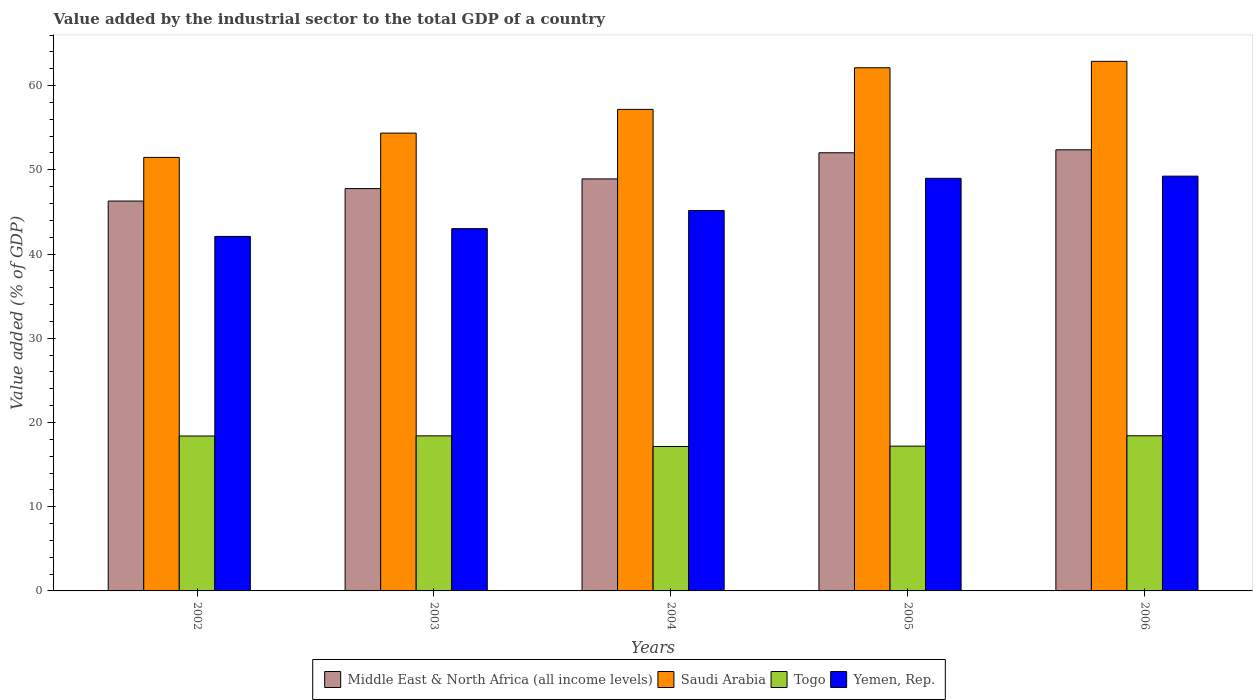How many groups of bars are there?
Offer a very short reply. 5. How many bars are there on the 4th tick from the left?
Ensure brevity in your answer.  4. How many bars are there on the 5th tick from the right?
Your answer should be very brief. 4. What is the value added by the industrial sector to the total GDP in Yemen, Rep. in 2004?
Your answer should be compact. 45.16. Across all years, what is the maximum value added by the industrial sector to the total GDP in Saudi Arabia?
Make the answer very short. 62.88. Across all years, what is the minimum value added by the industrial sector to the total GDP in Yemen, Rep.?
Keep it short and to the point. 42.09. In which year was the value added by the industrial sector to the total GDP in Yemen, Rep. minimum?
Your answer should be compact. 2002. What is the total value added by the industrial sector to the total GDP in Togo in the graph?
Make the answer very short. 89.56. What is the difference between the value added by the industrial sector to the total GDP in Togo in 2005 and that in 2006?
Your answer should be compact. -1.23. What is the difference between the value added by the industrial sector to the total GDP in Yemen, Rep. in 2006 and the value added by the industrial sector to the total GDP in Saudi Arabia in 2004?
Keep it short and to the point. -7.93. What is the average value added by the industrial sector to the total GDP in Togo per year?
Keep it short and to the point. 17.91. In the year 2002, what is the difference between the value added by the industrial sector to the total GDP in Yemen, Rep. and value added by the industrial sector to the total GDP in Middle East & North Africa (all income levels)?
Provide a short and direct response. -4.2. In how many years, is the value added by the industrial sector to the total GDP in Saudi Arabia greater than 56 %?
Provide a succinct answer. 3. What is the ratio of the value added by the industrial sector to the total GDP in Middle East & North Africa (all income levels) in 2002 to that in 2003?
Offer a very short reply. 0.97. Is the difference between the value added by the industrial sector to the total GDP in Yemen, Rep. in 2003 and 2005 greater than the difference between the value added by the industrial sector to the total GDP in Middle East & North Africa (all income levels) in 2003 and 2005?
Provide a succinct answer. No. What is the difference between the highest and the second highest value added by the industrial sector to the total GDP in Togo?
Ensure brevity in your answer.  0.01. What is the difference between the highest and the lowest value added by the industrial sector to the total GDP in Togo?
Give a very brief answer. 1.28. In how many years, is the value added by the industrial sector to the total GDP in Middle East & North Africa (all income levels) greater than the average value added by the industrial sector to the total GDP in Middle East & North Africa (all income levels) taken over all years?
Offer a terse response. 2. Is the sum of the value added by the industrial sector to the total GDP in Yemen, Rep. in 2002 and 2004 greater than the maximum value added by the industrial sector to the total GDP in Saudi Arabia across all years?
Provide a short and direct response. Yes. Is it the case that in every year, the sum of the value added by the industrial sector to the total GDP in Middle East & North Africa (all income levels) and value added by the industrial sector to the total GDP in Yemen, Rep. is greater than the sum of value added by the industrial sector to the total GDP in Saudi Arabia and value added by the industrial sector to the total GDP in Togo?
Your response must be concise. No. What does the 3rd bar from the left in 2006 represents?
Offer a terse response. Togo. What does the 1st bar from the right in 2002 represents?
Your response must be concise. Yemen, Rep. Is it the case that in every year, the sum of the value added by the industrial sector to the total GDP in Middle East & North Africa (all income levels) and value added by the industrial sector to the total GDP in Togo is greater than the value added by the industrial sector to the total GDP in Yemen, Rep.?
Your answer should be very brief. Yes. How many years are there in the graph?
Your answer should be very brief. 5. Does the graph contain any zero values?
Your response must be concise. No. Does the graph contain grids?
Offer a very short reply. No. How are the legend labels stacked?
Your answer should be very brief. Horizontal. What is the title of the graph?
Give a very brief answer. Value added by the industrial sector to the total GDP of a country. Does "Vietnam" appear as one of the legend labels in the graph?
Your response must be concise. No. What is the label or title of the X-axis?
Provide a short and direct response. Years. What is the label or title of the Y-axis?
Your answer should be compact. Value added (% of GDP). What is the Value added (% of GDP) of Middle East & North Africa (all income levels) in 2002?
Make the answer very short. 46.29. What is the Value added (% of GDP) of Saudi Arabia in 2002?
Provide a succinct answer. 51.47. What is the Value added (% of GDP) of Togo in 2002?
Provide a short and direct response. 18.39. What is the Value added (% of GDP) of Yemen, Rep. in 2002?
Give a very brief answer. 42.09. What is the Value added (% of GDP) of Middle East & North Africa (all income levels) in 2003?
Keep it short and to the point. 47.77. What is the Value added (% of GDP) in Saudi Arabia in 2003?
Provide a succinct answer. 54.36. What is the Value added (% of GDP) of Togo in 2003?
Your response must be concise. 18.41. What is the Value added (% of GDP) of Yemen, Rep. in 2003?
Make the answer very short. 43.01. What is the Value added (% of GDP) in Middle East & North Africa (all income levels) in 2004?
Give a very brief answer. 48.92. What is the Value added (% of GDP) of Saudi Arabia in 2004?
Offer a terse response. 57.17. What is the Value added (% of GDP) in Togo in 2004?
Offer a very short reply. 17.15. What is the Value added (% of GDP) of Yemen, Rep. in 2004?
Provide a succinct answer. 45.16. What is the Value added (% of GDP) of Middle East & North Africa (all income levels) in 2005?
Your answer should be very brief. 52.02. What is the Value added (% of GDP) in Saudi Arabia in 2005?
Offer a very short reply. 62.11. What is the Value added (% of GDP) of Togo in 2005?
Keep it short and to the point. 17.19. What is the Value added (% of GDP) in Yemen, Rep. in 2005?
Keep it short and to the point. 48.99. What is the Value added (% of GDP) in Middle East & North Africa (all income levels) in 2006?
Provide a succinct answer. 52.37. What is the Value added (% of GDP) of Saudi Arabia in 2006?
Your answer should be compact. 62.88. What is the Value added (% of GDP) in Togo in 2006?
Your response must be concise. 18.42. What is the Value added (% of GDP) of Yemen, Rep. in 2006?
Provide a succinct answer. 49.25. Across all years, what is the maximum Value added (% of GDP) of Middle East & North Africa (all income levels)?
Provide a short and direct response. 52.37. Across all years, what is the maximum Value added (% of GDP) in Saudi Arabia?
Keep it short and to the point. 62.88. Across all years, what is the maximum Value added (% of GDP) in Togo?
Your response must be concise. 18.42. Across all years, what is the maximum Value added (% of GDP) of Yemen, Rep.?
Provide a succinct answer. 49.25. Across all years, what is the minimum Value added (% of GDP) in Middle East & North Africa (all income levels)?
Offer a terse response. 46.29. Across all years, what is the minimum Value added (% of GDP) in Saudi Arabia?
Provide a succinct answer. 51.47. Across all years, what is the minimum Value added (% of GDP) of Togo?
Your response must be concise. 17.15. Across all years, what is the minimum Value added (% of GDP) of Yemen, Rep.?
Your answer should be compact. 42.09. What is the total Value added (% of GDP) of Middle East & North Africa (all income levels) in the graph?
Provide a short and direct response. 247.38. What is the total Value added (% of GDP) in Saudi Arabia in the graph?
Make the answer very short. 288. What is the total Value added (% of GDP) of Togo in the graph?
Give a very brief answer. 89.56. What is the total Value added (% of GDP) of Yemen, Rep. in the graph?
Give a very brief answer. 228.5. What is the difference between the Value added (% of GDP) in Middle East & North Africa (all income levels) in 2002 and that in 2003?
Provide a short and direct response. -1.48. What is the difference between the Value added (% of GDP) of Saudi Arabia in 2002 and that in 2003?
Your answer should be compact. -2.89. What is the difference between the Value added (% of GDP) in Togo in 2002 and that in 2003?
Make the answer very short. -0.02. What is the difference between the Value added (% of GDP) in Yemen, Rep. in 2002 and that in 2003?
Your answer should be very brief. -0.93. What is the difference between the Value added (% of GDP) of Middle East & North Africa (all income levels) in 2002 and that in 2004?
Make the answer very short. -2.63. What is the difference between the Value added (% of GDP) in Saudi Arabia in 2002 and that in 2004?
Keep it short and to the point. -5.7. What is the difference between the Value added (% of GDP) of Togo in 2002 and that in 2004?
Provide a short and direct response. 1.25. What is the difference between the Value added (% of GDP) of Yemen, Rep. in 2002 and that in 2004?
Provide a succinct answer. -3.08. What is the difference between the Value added (% of GDP) of Middle East & North Africa (all income levels) in 2002 and that in 2005?
Your answer should be very brief. -5.73. What is the difference between the Value added (% of GDP) in Saudi Arabia in 2002 and that in 2005?
Make the answer very short. -10.64. What is the difference between the Value added (% of GDP) of Togo in 2002 and that in 2005?
Your answer should be very brief. 1.2. What is the difference between the Value added (% of GDP) of Yemen, Rep. in 2002 and that in 2005?
Your answer should be compact. -6.9. What is the difference between the Value added (% of GDP) in Middle East & North Africa (all income levels) in 2002 and that in 2006?
Give a very brief answer. -6.08. What is the difference between the Value added (% of GDP) of Saudi Arabia in 2002 and that in 2006?
Your answer should be very brief. -11.4. What is the difference between the Value added (% of GDP) of Togo in 2002 and that in 2006?
Provide a succinct answer. -0.03. What is the difference between the Value added (% of GDP) of Yemen, Rep. in 2002 and that in 2006?
Give a very brief answer. -7.16. What is the difference between the Value added (% of GDP) in Middle East & North Africa (all income levels) in 2003 and that in 2004?
Ensure brevity in your answer.  -1.15. What is the difference between the Value added (% of GDP) of Saudi Arabia in 2003 and that in 2004?
Your answer should be compact. -2.82. What is the difference between the Value added (% of GDP) of Togo in 2003 and that in 2004?
Give a very brief answer. 1.26. What is the difference between the Value added (% of GDP) in Yemen, Rep. in 2003 and that in 2004?
Your answer should be compact. -2.15. What is the difference between the Value added (% of GDP) in Middle East & North Africa (all income levels) in 2003 and that in 2005?
Ensure brevity in your answer.  -4.25. What is the difference between the Value added (% of GDP) in Saudi Arabia in 2003 and that in 2005?
Offer a very short reply. -7.76. What is the difference between the Value added (% of GDP) of Togo in 2003 and that in 2005?
Make the answer very short. 1.22. What is the difference between the Value added (% of GDP) in Yemen, Rep. in 2003 and that in 2005?
Provide a short and direct response. -5.97. What is the difference between the Value added (% of GDP) in Middle East & North Africa (all income levels) in 2003 and that in 2006?
Make the answer very short. -4.61. What is the difference between the Value added (% of GDP) in Saudi Arabia in 2003 and that in 2006?
Keep it short and to the point. -8.52. What is the difference between the Value added (% of GDP) in Togo in 2003 and that in 2006?
Ensure brevity in your answer.  -0.01. What is the difference between the Value added (% of GDP) of Yemen, Rep. in 2003 and that in 2006?
Keep it short and to the point. -6.23. What is the difference between the Value added (% of GDP) in Middle East & North Africa (all income levels) in 2004 and that in 2005?
Offer a very short reply. -3.1. What is the difference between the Value added (% of GDP) of Saudi Arabia in 2004 and that in 2005?
Offer a very short reply. -4.94. What is the difference between the Value added (% of GDP) in Togo in 2004 and that in 2005?
Make the answer very short. -0.04. What is the difference between the Value added (% of GDP) of Yemen, Rep. in 2004 and that in 2005?
Offer a very short reply. -3.83. What is the difference between the Value added (% of GDP) in Middle East & North Africa (all income levels) in 2004 and that in 2006?
Your answer should be very brief. -3.46. What is the difference between the Value added (% of GDP) of Saudi Arabia in 2004 and that in 2006?
Offer a very short reply. -5.7. What is the difference between the Value added (% of GDP) in Togo in 2004 and that in 2006?
Offer a terse response. -1.28. What is the difference between the Value added (% of GDP) in Yemen, Rep. in 2004 and that in 2006?
Provide a short and direct response. -4.08. What is the difference between the Value added (% of GDP) in Middle East & North Africa (all income levels) in 2005 and that in 2006?
Offer a very short reply. -0.35. What is the difference between the Value added (% of GDP) in Saudi Arabia in 2005 and that in 2006?
Offer a terse response. -0.76. What is the difference between the Value added (% of GDP) in Togo in 2005 and that in 2006?
Offer a terse response. -1.23. What is the difference between the Value added (% of GDP) in Yemen, Rep. in 2005 and that in 2006?
Ensure brevity in your answer.  -0.26. What is the difference between the Value added (% of GDP) in Middle East & North Africa (all income levels) in 2002 and the Value added (% of GDP) in Saudi Arabia in 2003?
Keep it short and to the point. -8.07. What is the difference between the Value added (% of GDP) in Middle East & North Africa (all income levels) in 2002 and the Value added (% of GDP) in Togo in 2003?
Give a very brief answer. 27.88. What is the difference between the Value added (% of GDP) of Middle East & North Africa (all income levels) in 2002 and the Value added (% of GDP) of Yemen, Rep. in 2003?
Offer a very short reply. 3.28. What is the difference between the Value added (% of GDP) in Saudi Arabia in 2002 and the Value added (% of GDP) in Togo in 2003?
Keep it short and to the point. 33.06. What is the difference between the Value added (% of GDP) in Saudi Arabia in 2002 and the Value added (% of GDP) in Yemen, Rep. in 2003?
Keep it short and to the point. 8.46. What is the difference between the Value added (% of GDP) of Togo in 2002 and the Value added (% of GDP) of Yemen, Rep. in 2003?
Your answer should be compact. -24.62. What is the difference between the Value added (% of GDP) in Middle East & North Africa (all income levels) in 2002 and the Value added (% of GDP) in Saudi Arabia in 2004?
Provide a succinct answer. -10.88. What is the difference between the Value added (% of GDP) in Middle East & North Africa (all income levels) in 2002 and the Value added (% of GDP) in Togo in 2004?
Provide a short and direct response. 29.14. What is the difference between the Value added (% of GDP) in Middle East & North Africa (all income levels) in 2002 and the Value added (% of GDP) in Yemen, Rep. in 2004?
Offer a terse response. 1.13. What is the difference between the Value added (% of GDP) in Saudi Arabia in 2002 and the Value added (% of GDP) in Togo in 2004?
Ensure brevity in your answer.  34.33. What is the difference between the Value added (% of GDP) in Saudi Arabia in 2002 and the Value added (% of GDP) in Yemen, Rep. in 2004?
Offer a very short reply. 6.31. What is the difference between the Value added (% of GDP) in Togo in 2002 and the Value added (% of GDP) in Yemen, Rep. in 2004?
Offer a terse response. -26.77. What is the difference between the Value added (% of GDP) of Middle East & North Africa (all income levels) in 2002 and the Value added (% of GDP) of Saudi Arabia in 2005?
Your answer should be very brief. -15.82. What is the difference between the Value added (% of GDP) of Middle East & North Africa (all income levels) in 2002 and the Value added (% of GDP) of Togo in 2005?
Make the answer very short. 29.1. What is the difference between the Value added (% of GDP) of Middle East & North Africa (all income levels) in 2002 and the Value added (% of GDP) of Yemen, Rep. in 2005?
Provide a succinct answer. -2.7. What is the difference between the Value added (% of GDP) in Saudi Arabia in 2002 and the Value added (% of GDP) in Togo in 2005?
Ensure brevity in your answer.  34.28. What is the difference between the Value added (% of GDP) in Saudi Arabia in 2002 and the Value added (% of GDP) in Yemen, Rep. in 2005?
Your answer should be very brief. 2.48. What is the difference between the Value added (% of GDP) in Togo in 2002 and the Value added (% of GDP) in Yemen, Rep. in 2005?
Your response must be concise. -30.6. What is the difference between the Value added (% of GDP) in Middle East & North Africa (all income levels) in 2002 and the Value added (% of GDP) in Saudi Arabia in 2006?
Provide a short and direct response. -16.59. What is the difference between the Value added (% of GDP) in Middle East & North Africa (all income levels) in 2002 and the Value added (% of GDP) in Togo in 2006?
Ensure brevity in your answer.  27.87. What is the difference between the Value added (% of GDP) of Middle East & North Africa (all income levels) in 2002 and the Value added (% of GDP) of Yemen, Rep. in 2006?
Offer a terse response. -2.96. What is the difference between the Value added (% of GDP) in Saudi Arabia in 2002 and the Value added (% of GDP) in Togo in 2006?
Ensure brevity in your answer.  33.05. What is the difference between the Value added (% of GDP) in Saudi Arabia in 2002 and the Value added (% of GDP) in Yemen, Rep. in 2006?
Offer a very short reply. 2.22. What is the difference between the Value added (% of GDP) in Togo in 2002 and the Value added (% of GDP) in Yemen, Rep. in 2006?
Offer a very short reply. -30.85. What is the difference between the Value added (% of GDP) of Middle East & North Africa (all income levels) in 2003 and the Value added (% of GDP) of Saudi Arabia in 2004?
Ensure brevity in your answer.  -9.41. What is the difference between the Value added (% of GDP) in Middle East & North Africa (all income levels) in 2003 and the Value added (% of GDP) in Togo in 2004?
Ensure brevity in your answer.  30.62. What is the difference between the Value added (% of GDP) of Middle East & North Africa (all income levels) in 2003 and the Value added (% of GDP) of Yemen, Rep. in 2004?
Your response must be concise. 2.61. What is the difference between the Value added (% of GDP) in Saudi Arabia in 2003 and the Value added (% of GDP) in Togo in 2004?
Your response must be concise. 37.21. What is the difference between the Value added (% of GDP) in Saudi Arabia in 2003 and the Value added (% of GDP) in Yemen, Rep. in 2004?
Offer a terse response. 9.19. What is the difference between the Value added (% of GDP) in Togo in 2003 and the Value added (% of GDP) in Yemen, Rep. in 2004?
Give a very brief answer. -26.75. What is the difference between the Value added (% of GDP) in Middle East & North Africa (all income levels) in 2003 and the Value added (% of GDP) in Saudi Arabia in 2005?
Ensure brevity in your answer.  -14.35. What is the difference between the Value added (% of GDP) in Middle East & North Africa (all income levels) in 2003 and the Value added (% of GDP) in Togo in 2005?
Offer a terse response. 30.58. What is the difference between the Value added (% of GDP) of Middle East & North Africa (all income levels) in 2003 and the Value added (% of GDP) of Yemen, Rep. in 2005?
Keep it short and to the point. -1.22. What is the difference between the Value added (% of GDP) in Saudi Arabia in 2003 and the Value added (% of GDP) in Togo in 2005?
Offer a very short reply. 37.17. What is the difference between the Value added (% of GDP) of Saudi Arabia in 2003 and the Value added (% of GDP) of Yemen, Rep. in 2005?
Offer a terse response. 5.37. What is the difference between the Value added (% of GDP) of Togo in 2003 and the Value added (% of GDP) of Yemen, Rep. in 2005?
Offer a terse response. -30.58. What is the difference between the Value added (% of GDP) in Middle East & North Africa (all income levels) in 2003 and the Value added (% of GDP) in Saudi Arabia in 2006?
Offer a terse response. -15.11. What is the difference between the Value added (% of GDP) in Middle East & North Africa (all income levels) in 2003 and the Value added (% of GDP) in Togo in 2006?
Keep it short and to the point. 29.35. What is the difference between the Value added (% of GDP) of Middle East & North Africa (all income levels) in 2003 and the Value added (% of GDP) of Yemen, Rep. in 2006?
Your response must be concise. -1.48. What is the difference between the Value added (% of GDP) of Saudi Arabia in 2003 and the Value added (% of GDP) of Togo in 2006?
Give a very brief answer. 35.93. What is the difference between the Value added (% of GDP) of Saudi Arabia in 2003 and the Value added (% of GDP) of Yemen, Rep. in 2006?
Make the answer very short. 5.11. What is the difference between the Value added (% of GDP) of Togo in 2003 and the Value added (% of GDP) of Yemen, Rep. in 2006?
Provide a succinct answer. -30.84. What is the difference between the Value added (% of GDP) of Middle East & North Africa (all income levels) in 2004 and the Value added (% of GDP) of Saudi Arabia in 2005?
Your answer should be compact. -13.2. What is the difference between the Value added (% of GDP) of Middle East & North Africa (all income levels) in 2004 and the Value added (% of GDP) of Togo in 2005?
Keep it short and to the point. 31.73. What is the difference between the Value added (% of GDP) of Middle East & North Africa (all income levels) in 2004 and the Value added (% of GDP) of Yemen, Rep. in 2005?
Make the answer very short. -0.07. What is the difference between the Value added (% of GDP) of Saudi Arabia in 2004 and the Value added (% of GDP) of Togo in 2005?
Ensure brevity in your answer.  39.99. What is the difference between the Value added (% of GDP) of Saudi Arabia in 2004 and the Value added (% of GDP) of Yemen, Rep. in 2005?
Your answer should be very brief. 8.19. What is the difference between the Value added (% of GDP) of Togo in 2004 and the Value added (% of GDP) of Yemen, Rep. in 2005?
Give a very brief answer. -31.84. What is the difference between the Value added (% of GDP) of Middle East & North Africa (all income levels) in 2004 and the Value added (% of GDP) of Saudi Arabia in 2006?
Your response must be concise. -13.96. What is the difference between the Value added (% of GDP) of Middle East & North Africa (all income levels) in 2004 and the Value added (% of GDP) of Togo in 2006?
Make the answer very short. 30.5. What is the difference between the Value added (% of GDP) of Middle East & North Africa (all income levels) in 2004 and the Value added (% of GDP) of Yemen, Rep. in 2006?
Make the answer very short. -0.33. What is the difference between the Value added (% of GDP) of Saudi Arabia in 2004 and the Value added (% of GDP) of Togo in 2006?
Your response must be concise. 38.75. What is the difference between the Value added (% of GDP) in Saudi Arabia in 2004 and the Value added (% of GDP) in Yemen, Rep. in 2006?
Provide a short and direct response. 7.93. What is the difference between the Value added (% of GDP) in Togo in 2004 and the Value added (% of GDP) in Yemen, Rep. in 2006?
Provide a short and direct response. -32.1. What is the difference between the Value added (% of GDP) in Middle East & North Africa (all income levels) in 2005 and the Value added (% of GDP) in Saudi Arabia in 2006?
Provide a succinct answer. -10.85. What is the difference between the Value added (% of GDP) of Middle East & North Africa (all income levels) in 2005 and the Value added (% of GDP) of Togo in 2006?
Keep it short and to the point. 33.6. What is the difference between the Value added (% of GDP) in Middle East & North Africa (all income levels) in 2005 and the Value added (% of GDP) in Yemen, Rep. in 2006?
Provide a succinct answer. 2.78. What is the difference between the Value added (% of GDP) in Saudi Arabia in 2005 and the Value added (% of GDP) in Togo in 2006?
Provide a succinct answer. 43.69. What is the difference between the Value added (% of GDP) in Saudi Arabia in 2005 and the Value added (% of GDP) in Yemen, Rep. in 2006?
Provide a succinct answer. 12.87. What is the difference between the Value added (% of GDP) in Togo in 2005 and the Value added (% of GDP) in Yemen, Rep. in 2006?
Your answer should be compact. -32.06. What is the average Value added (% of GDP) of Middle East & North Africa (all income levels) per year?
Give a very brief answer. 49.48. What is the average Value added (% of GDP) in Saudi Arabia per year?
Provide a short and direct response. 57.6. What is the average Value added (% of GDP) in Togo per year?
Ensure brevity in your answer.  17.91. What is the average Value added (% of GDP) in Yemen, Rep. per year?
Give a very brief answer. 45.7. In the year 2002, what is the difference between the Value added (% of GDP) in Middle East & North Africa (all income levels) and Value added (% of GDP) in Saudi Arabia?
Your response must be concise. -5.18. In the year 2002, what is the difference between the Value added (% of GDP) of Middle East & North Africa (all income levels) and Value added (% of GDP) of Togo?
Offer a very short reply. 27.9. In the year 2002, what is the difference between the Value added (% of GDP) of Middle East & North Africa (all income levels) and Value added (% of GDP) of Yemen, Rep.?
Your response must be concise. 4.2. In the year 2002, what is the difference between the Value added (% of GDP) of Saudi Arabia and Value added (% of GDP) of Togo?
Offer a very short reply. 33.08. In the year 2002, what is the difference between the Value added (% of GDP) in Saudi Arabia and Value added (% of GDP) in Yemen, Rep.?
Make the answer very short. 9.38. In the year 2002, what is the difference between the Value added (% of GDP) in Togo and Value added (% of GDP) in Yemen, Rep.?
Ensure brevity in your answer.  -23.69. In the year 2003, what is the difference between the Value added (% of GDP) in Middle East & North Africa (all income levels) and Value added (% of GDP) in Saudi Arabia?
Your response must be concise. -6.59. In the year 2003, what is the difference between the Value added (% of GDP) of Middle East & North Africa (all income levels) and Value added (% of GDP) of Togo?
Keep it short and to the point. 29.36. In the year 2003, what is the difference between the Value added (% of GDP) of Middle East & North Africa (all income levels) and Value added (% of GDP) of Yemen, Rep.?
Your response must be concise. 4.75. In the year 2003, what is the difference between the Value added (% of GDP) of Saudi Arabia and Value added (% of GDP) of Togo?
Keep it short and to the point. 35.95. In the year 2003, what is the difference between the Value added (% of GDP) of Saudi Arabia and Value added (% of GDP) of Yemen, Rep.?
Give a very brief answer. 11.34. In the year 2003, what is the difference between the Value added (% of GDP) in Togo and Value added (% of GDP) in Yemen, Rep.?
Your answer should be compact. -24.6. In the year 2004, what is the difference between the Value added (% of GDP) of Middle East & North Africa (all income levels) and Value added (% of GDP) of Saudi Arabia?
Your answer should be compact. -8.26. In the year 2004, what is the difference between the Value added (% of GDP) of Middle East & North Africa (all income levels) and Value added (% of GDP) of Togo?
Your response must be concise. 31.77. In the year 2004, what is the difference between the Value added (% of GDP) of Middle East & North Africa (all income levels) and Value added (% of GDP) of Yemen, Rep.?
Keep it short and to the point. 3.75. In the year 2004, what is the difference between the Value added (% of GDP) of Saudi Arabia and Value added (% of GDP) of Togo?
Offer a very short reply. 40.03. In the year 2004, what is the difference between the Value added (% of GDP) in Saudi Arabia and Value added (% of GDP) in Yemen, Rep.?
Make the answer very short. 12.01. In the year 2004, what is the difference between the Value added (% of GDP) in Togo and Value added (% of GDP) in Yemen, Rep.?
Offer a terse response. -28.02. In the year 2005, what is the difference between the Value added (% of GDP) in Middle East & North Africa (all income levels) and Value added (% of GDP) in Saudi Arabia?
Provide a short and direct response. -10.09. In the year 2005, what is the difference between the Value added (% of GDP) in Middle East & North Africa (all income levels) and Value added (% of GDP) in Togo?
Your answer should be compact. 34.83. In the year 2005, what is the difference between the Value added (% of GDP) in Middle East & North Africa (all income levels) and Value added (% of GDP) in Yemen, Rep.?
Provide a short and direct response. 3.03. In the year 2005, what is the difference between the Value added (% of GDP) of Saudi Arabia and Value added (% of GDP) of Togo?
Offer a terse response. 44.93. In the year 2005, what is the difference between the Value added (% of GDP) of Saudi Arabia and Value added (% of GDP) of Yemen, Rep.?
Provide a short and direct response. 13.13. In the year 2005, what is the difference between the Value added (% of GDP) in Togo and Value added (% of GDP) in Yemen, Rep.?
Your response must be concise. -31.8. In the year 2006, what is the difference between the Value added (% of GDP) of Middle East & North Africa (all income levels) and Value added (% of GDP) of Saudi Arabia?
Provide a short and direct response. -10.5. In the year 2006, what is the difference between the Value added (% of GDP) of Middle East & North Africa (all income levels) and Value added (% of GDP) of Togo?
Your response must be concise. 33.95. In the year 2006, what is the difference between the Value added (% of GDP) of Middle East & North Africa (all income levels) and Value added (% of GDP) of Yemen, Rep.?
Ensure brevity in your answer.  3.13. In the year 2006, what is the difference between the Value added (% of GDP) of Saudi Arabia and Value added (% of GDP) of Togo?
Provide a short and direct response. 44.45. In the year 2006, what is the difference between the Value added (% of GDP) of Saudi Arabia and Value added (% of GDP) of Yemen, Rep.?
Make the answer very short. 13.63. In the year 2006, what is the difference between the Value added (% of GDP) of Togo and Value added (% of GDP) of Yemen, Rep.?
Offer a very short reply. -30.82. What is the ratio of the Value added (% of GDP) in Middle East & North Africa (all income levels) in 2002 to that in 2003?
Your answer should be compact. 0.97. What is the ratio of the Value added (% of GDP) in Saudi Arabia in 2002 to that in 2003?
Your answer should be compact. 0.95. What is the ratio of the Value added (% of GDP) in Togo in 2002 to that in 2003?
Your response must be concise. 1. What is the ratio of the Value added (% of GDP) of Yemen, Rep. in 2002 to that in 2003?
Ensure brevity in your answer.  0.98. What is the ratio of the Value added (% of GDP) of Middle East & North Africa (all income levels) in 2002 to that in 2004?
Keep it short and to the point. 0.95. What is the ratio of the Value added (% of GDP) of Saudi Arabia in 2002 to that in 2004?
Offer a terse response. 0.9. What is the ratio of the Value added (% of GDP) in Togo in 2002 to that in 2004?
Your answer should be compact. 1.07. What is the ratio of the Value added (% of GDP) of Yemen, Rep. in 2002 to that in 2004?
Your answer should be compact. 0.93. What is the ratio of the Value added (% of GDP) of Middle East & North Africa (all income levels) in 2002 to that in 2005?
Your answer should be very brief. 0.89. What is the ratio of the Value added (% of GDP) of Saudi Arabia in 2002 to that in 2005?
Provide a succinct answer. 0.83. What is the ratio of the Value added (% of GDP) of Togo in 2002 to that in 2005?
Make the answer very short. 1.07. What is the ratio of the Value added (% of GDP) in Yemen, Rep. in 2002 to that in 2005?
Make the answer very short. 0.86. What is the ratio of the Value added (% of GDP) in Middle East & North Africa (all income levels) in 2002 to that in 2006?
Ensure brevity in your answer.  0.88. What is the ratio of the Value added (% of GDP) of Saudi Arabia in 2002 to that in 2006?
Make the answer very short. 0.82. What is the ratio of the Value added (% of GDP) in Yemen, Rep. in 2002 to that in 2006?
Offer a very short reply. 0.85. What is the ratio of the Value added (% of GDP) of Middle East & North Africa (all income levels) in 2003 to that in 2004?
Ensure brevity in your answer.  0.98. What is the ratio of the Value added (% of GDP) in Saudi Arabia in 2003 to that in 2004?
Ensure brevity in your answer.  0.95. What is the ratio of the Value added (% of GDP) of Togo in 2003 to that in 2004?
Your answer should be very brief. 1.07. What is the ratio of the Value added (% of GDP) in Yemen, Rep. in 2003 to that in 2004?
Ensure brevity in your answer.  0.95. What is the ratio of the Value added (% of GDP) of Middle East & North Africa (all income levels) in 2003 to that in 2005?
Provide a succinct answer. 0.92. What is the ratio of the Value added (% of GDP) of Saudi Arabia in 2003 to that in 2005?
Keep it short and to the point. 0.88. What is the ratio of the Value added (% of GDP) in Togo in 2003 to that in 2005?
Offer a very short reply. 1.07. What is the ratio of the Value added (% of GDP) in Yemen, Rep. in 2003 to that in 2005?
Offer a very short reply. 0.88. What is the ratio of the Value added (% of GDP) in Middle East & North Africa (all income levels) in 2003 to that in 2006?
Your response must be concise. 0.91. What is the ratio of the Value added (% of GDP) in Saudi Arabia in 2003 to that in 2006?
Provide a succinct answer. 0.86. What is the ratio of the Value added (% of GDP) of Yemen, Rep. in 2003 to that in 2006?
Provide a short and direct response. 0.87. What is the ratio of the Value added (% of GDP) in Middle East & North Africa (all income levels) in 2004 to that in 2005?
Give a very brief answer. 0.94. What is the ratio of the Value added (% of GDP) of Saudi Arabia in 2004 to that in 2005?
Offer a very short reply. 0.92. What is the ratio of the Value added (% of GDP) in Togo in 2004 to that in 2005?
Give a very brief answer. 1. What is the ratio of the Value added (% of GDP) of Yemen, Rep. in 2004 to that in 2005?
Make the answer very short. 0.92. What is the ratio of the Value added (% of GDP) of Middle East & North Africa (all income levels) in 2004 to that in 2006?
Your answer should be compact. 0.93. What is the ratio of the Value added (% of GDP) of Saudi Arabia in 2004 to that in 2006?
Make the answer very short. 0.91. What is the ratio of the Value added (% of GDP) in Togo in 2004 to that in 2006?
Provide a succinct answer. 0.93. What is the ratio of the Value added (% of GDP) in Yemen, Rep. in 2004 to that in 2006?
Provide a succinct answer. 0.92. What is the ratio of the Value added (% of GDP) in Middle East & North Africa (all income levels) in 2005 to that in 2006?
Your answer should be compact. 0.99. What is the ratio of the Value added (% of GDP) in Saudi Arabia in 2005 to that in 2006?
Offer a very short reply. 0.99. What is the ratio of the Value added (% of GDP) in Togo in 2005 to that in 2006?
Offer a very short reply. 0.93. What is the ratio of the Value added (% of GDP) in Yemen, Rep. in 2005 to that in 2006?
Provide a short and direct response. 0.99. What is the difference between the highest and the second highest Value added (% of GDP) in Middle East & North Africa (all income levels)?
Your answer should be very brief. 0.35. What is the difference between the highest and the second highest Value added (% of GDP) in Saudi Arabia?
Your answer should be compact. 0.76. What is the difference between the highest and the second highest Value added (% of GDP) of Togo?
Provide a short and direct response. 0.01. What is the difference between the highest and the second highest Value added (% of GDP) of Yemen, Rep.?
Ensure brevity in your answer.  0.26. What is the difference between the highest and the lowest Value added (% of GDP) in Middle East & North Africa (all income levels)?
Your answer should be very brief. 6.08. What is the difference between the highest and the lowest Value added (% of GDP) of Saudi Arabia?
Ensure brevity in your answer.  11.4. What is the difference between the highest and the lowest Value added (% of GDP) in Togo?
Give a very brief answer. 1.28. What is the difference between the highest and the lowest Value added (% of GDP) in Yemen, Rep.?
Give a very brief answer. 7.16. 